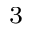<formula> <loc_0><loc_0><loc_500><loc_500>_ { 3 }</formula> 